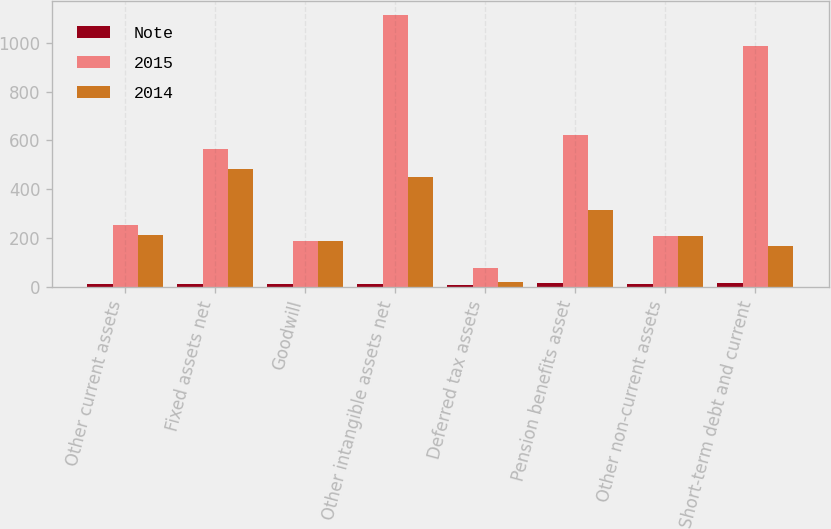Convert chart. <chart><loc_0><loc_0><loc_500><loc_500><stacked_bar_chart><ecel><fcel>Other current assets<fcel>Fixed assets net<fcel>Goodwill<fcel>Other intangible assets net<fcel>Deferred tax assets<fcel>Pension benefits asset<fcel>Other non-current assets<fcel>Short-term debt and current<nl><fcel>Note<fcel>14<fcel>11<fcel>12<fcel>13<fcel>8<fcel>17<fcel>14<fcel>18<nl><fcel>2015<fcel>255<fcel>563<fcel>188<fcel>1115<fcel>76<fcel>623<fcel>209<fcel>988<nl><fcel>2014<fcel>212<fcel>483<fcel>188<fcel>450<fcel>19<fcel>314<fcel>210<fcel>167<nl></chart> 